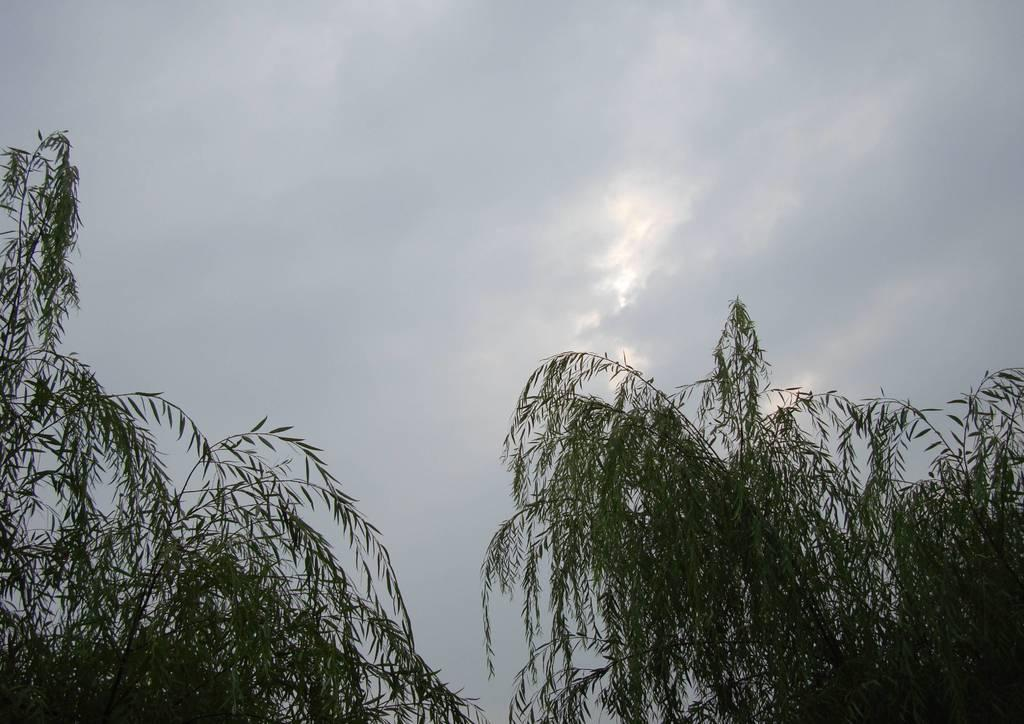What type of vegetation is in the front of the image? There are trees in the front of the image. What is visible in the background of the image? The sky is visible in the background of the image. How would you describe the sky's condition in the image? The sky is cloudy in the image. Can you see any cows grazing on clover near the trees in the image? There is no mention of cows or clover in the image; it only features trees and a cloudy sky. What type of vest is the tree wearing in the image? Trees do not wear vests, so this question is not applicable to the image. 